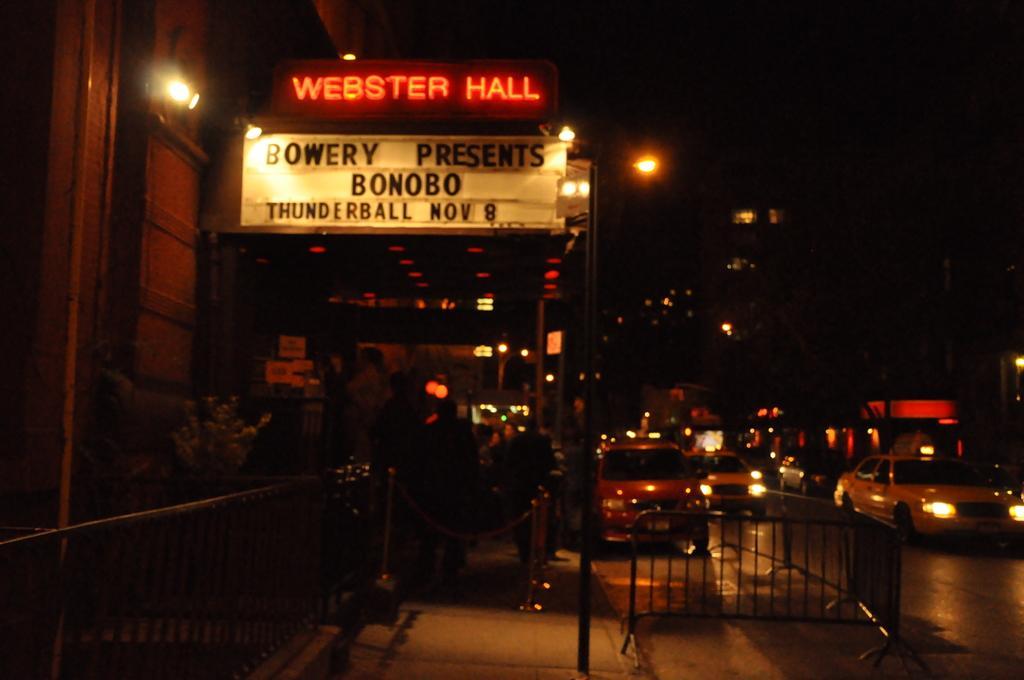Can you describe this image briefly? In this image there are a few vehicles are moving on the road. On the left and right side of the image there are buildings and trees, there is a board with some text. The background is dark. 